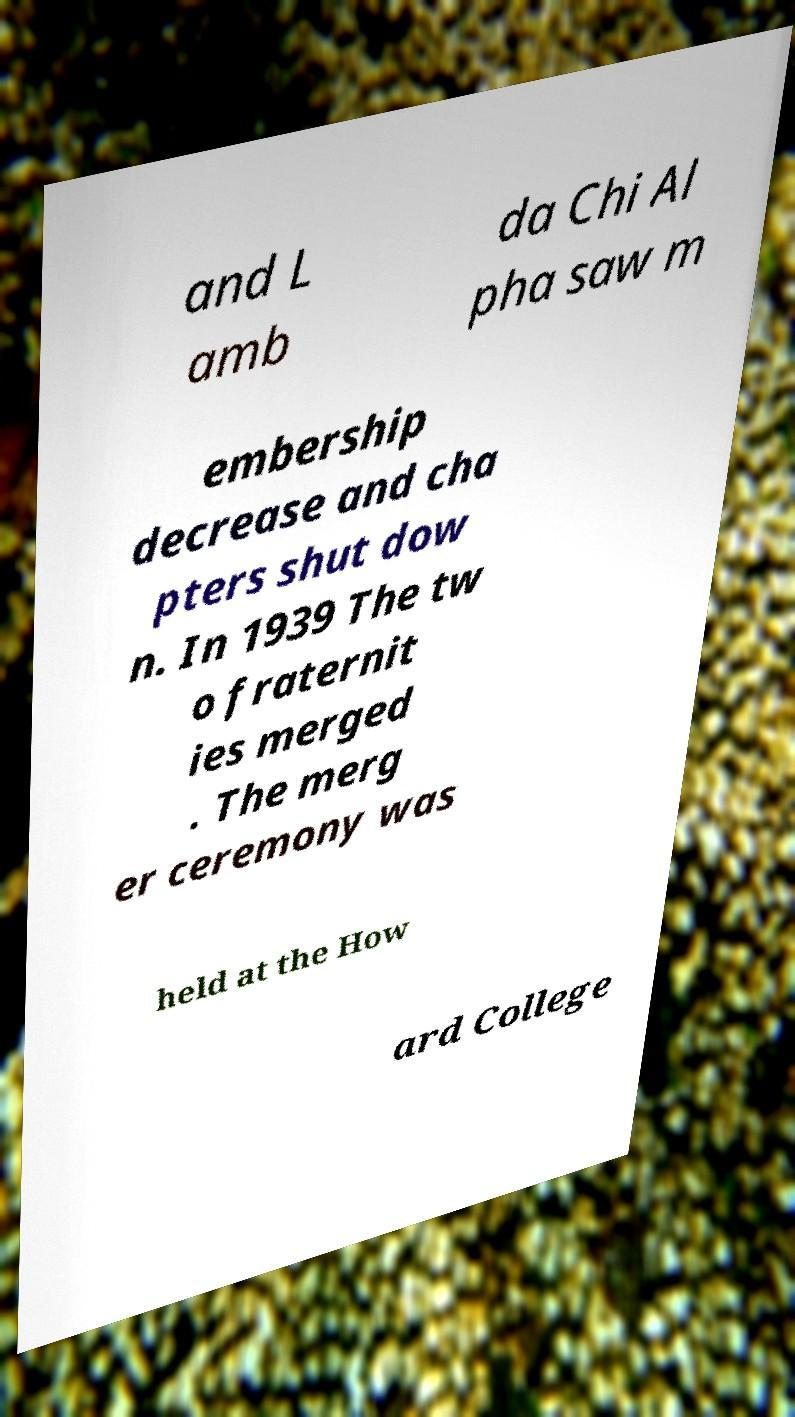Could you assist in decoding the text presented in this image and type it out clearly? and L amb da Chi Al pha saw m embership decrease and cha pters shut dow n. In 1939 The tw o fraternit ies merged . The merg er ceremony was held at the How ard College 